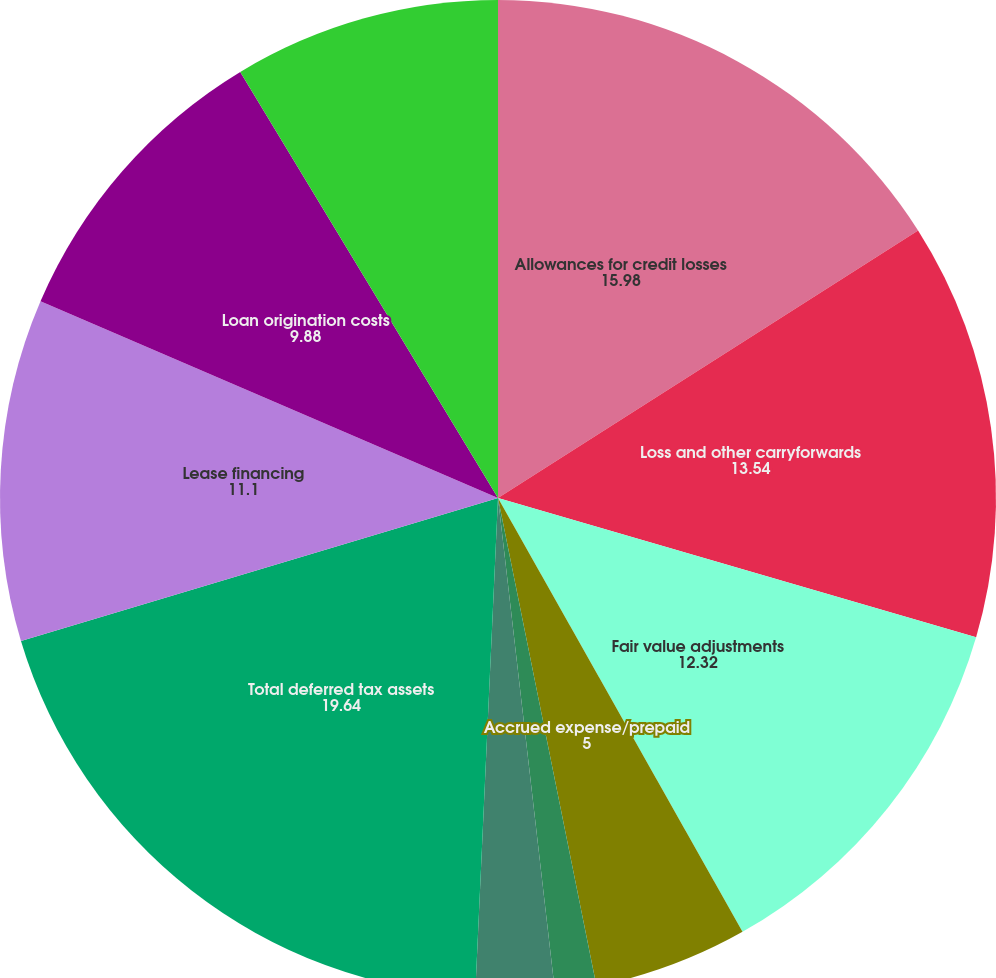Convert chart. <chart><loc_0><loc_0><loc_500><loc_500><pie_chart><fcel>Allowances for credit losses<fcel>Loss and other carryforwards<fcel>Fair value adjustments<fcel>Accrued expense/prepaid<fcel>Purchase accounting<fcel>Other<fcel>Total deferred tax assets<fcel>Lease financing<fcel>Loan origination costs<fcel>Mortgage servicing rights<nl><fcel>15.98%<fcel>13.54%<fcel>12.32%<fcel>5.0%<fcel>1.34%<fcel>2.56%<fcel>19.64%<fcel>11.1%<fcel>9.88%<fcel>8.66%<nl></chart> 